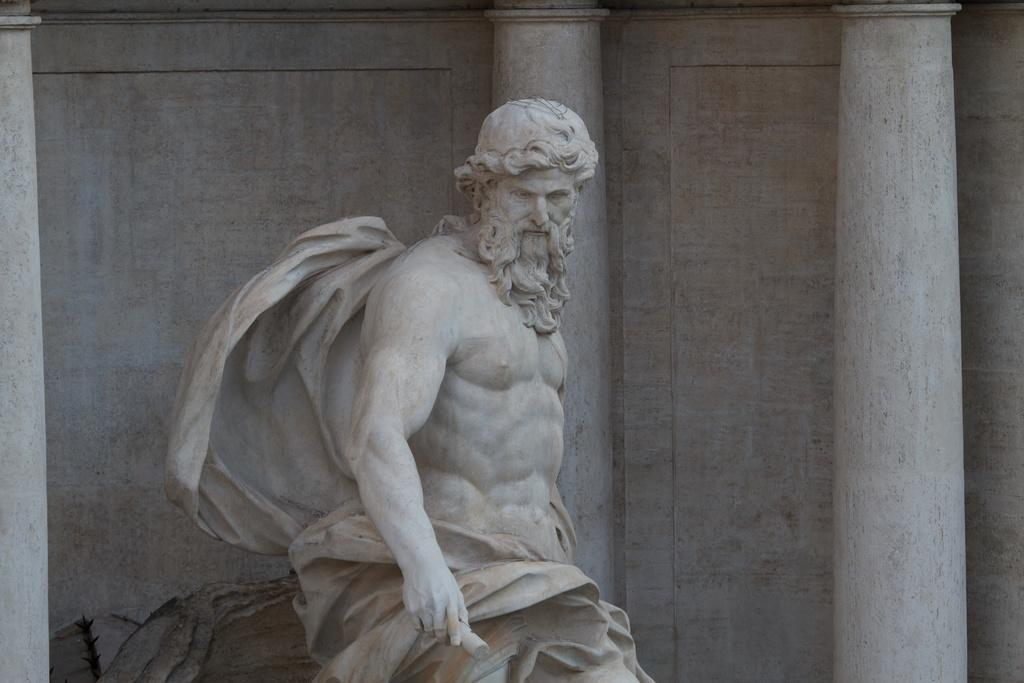What is the main subject in the foreground of the image? There is a sculpture in the foreground of the image. What can be seen in the background of the image? There is a wall in the image. Are there any architectural features present in the image? Yes, there are pillars in the image. What type of polish is being applied to the fairies in the image? There are no fairies or any mention of polish in the image; it features a sculpture and a wall with pillars. 